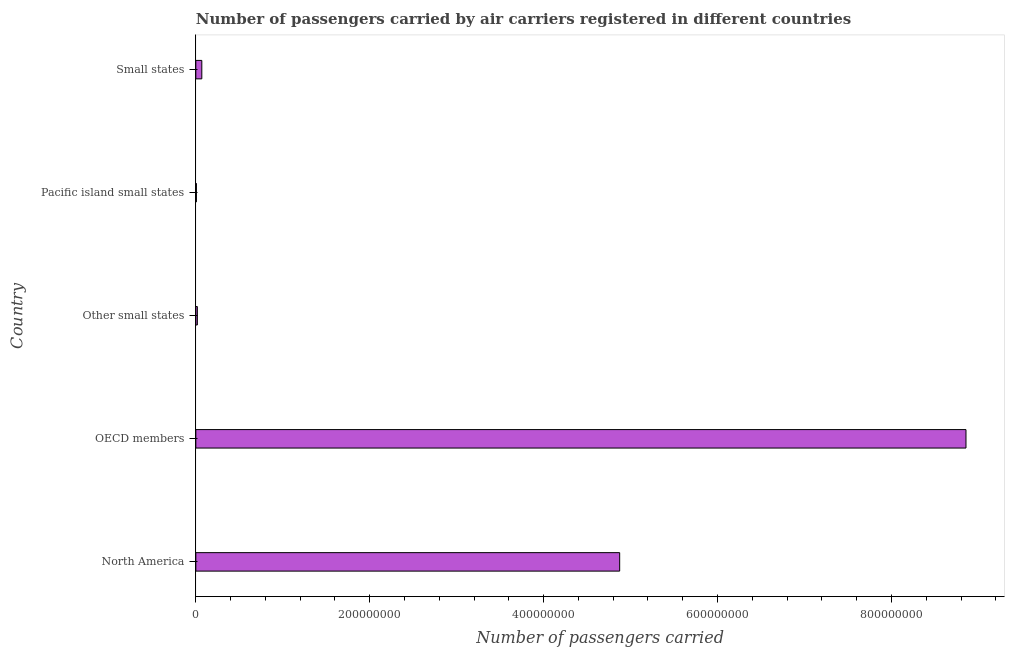Does the graph contain any zero values?
Keep it short and to the point. No. Does the graph contain grids?
Ensure brevity in your answer.  No. What is the title of the graph?
Ensure brevity in your answer.  Number of passengers carried by air carriers registered in different countries. What is the label or title of the X-axis?
Offer a terse response. Number of passengers carried. What is the number of passengers carried in Other small states?
Your answer should be very brief. 1.75e+06. Across all countries, what is the maximum number of passengers carried?
Offer a terse response. 8.86e+08. Across all countries, what is the minimum number of passengers carried?
Keep it short and to the point. 6.70e+05. In which country was the number of passengers carried maximum?
Provide a succinct answer. OECD members. In which country was the number of passengers carried minimum?
Offer a terse response. Pacific island small states. What is the sum of the number of passengers carried?
Your response must be concise. 1.38e+09. What is the difference between the number of passengers carried in OECD members and Other small states?
Give a very brief answer. 8.84e+08. What is the average number of passengers carried per country?
Your answer should be compact. 2.76e+08. What is the median number of passengers carried?
Your answer should be very brief. 6.88e+06. In how many countries, is the number of passengers carried greater than 160000000 ?
Keep it short and to the point. 2. What is the ratio of the number of passengers carried in North America to that in Pacific island small states?
Ensure brevity in your answer.  727.63. Is the number of passengers carried in OECD members less than that in Other small states?
Provide a succinct answer. No. Is the difference between the number of passengers carried in North America and Pacific island small states greater than the difference between any two countries?
Your answer should be compact. No. What is the difference between the highest and the second highest number of passengers carried?
Your response must be concise. 3.98e+08. Is the sum of the number of passengers carried in OECD members and Other small states greater than the maximum number of passengers carried across all countries?
Provide a short and direct response. Yes. What is the difference between the highest and the lowest number of passengers carried?
Provide a succinct answer. 8.85e+08. In how many countries, is the number of passengers carried greater than the average number of passengers carried taken over all countries?
Make the answer very short. 2. How many countries are there in the graph?
Keep it short and to the point. 5. What is the difference between two consecutive major ticks on the X-axis?
Your answer should be compact. 2.00e+08. Are the values on the major ticks of X-axis written in scientific E-notation?
Your response must be concise. No. What is the Number of passengers carried of North America?
Provide a succinct answer. 4.87e+08. What is the Number of passengers carried in OECD members?
Offer a terse response. 8.86e+08. What is the Number of passengers carried in Other small states?
Provide a short and direct response. 1.75e+06. What is the Number of passengers carried in Pacific island small states?
Your answer should be compact. 6.70e+05. What is the Number of passengers carried of Small states?
Give a very brief answer. 6.88e+06. What is the difference between the Number of passengers carried in North America and OECD members?
Give a very brief answer. -3.98e+08. What is the difference between the Number of passengers carried in North America and Other small states?
Provide a short and direct response. 4.86e+08. What is the difference between the Number of passengers carried in North America and Pacific island small states?
Your answer should be compact. 4.87e+08. What is the difference between the Number of passengers carried in North America and Small states?
Your response must be concise. 4.81e+08. What is the difference between the Number of passengers carried in OECD members and Other small states?
Provide a short and direct response. 8.84e+08. What is the difference between the Number of passengers carried in OECD members and Pacific island small states?
Ensure brevity in your answer.  8.85e+08. What is the difference between the Number of passengers carried in OECD members and Small states?
Ensure brevity in your answer.  8.79e+08. What is the difference between the Number of passengers carried in Other small states and Pacific island small states?
Your answer should be very brief. 1.08e+06. What is the difference between the Number of passengers carried in Other small states and Small states?
Give a very brief answer. -5.12e+06. What is the difference between the Number of passengers carried in Pacific island small states and Small states?
Make the answer very short. -6.21e+06. What is the ratio of the Number of passengers carried in North America to that in OECD members?
Your answer should be very brief. 0.55. What is the ratio of the Number of passengers carried in North America to that in Other small states?
Offer a terse response. 277.81. What is the ratio of the Number of passengers carried in North America to that in Pacific island small states?
Make the answer very short. 727.63. What is the ratio of the Number of passengers carried in North America to that in Small states?
Keep it short and to the point. 70.85. What is the ratio of the Number of passengers carried in OECD members to that in Other small states?
Offer a very short reply. 504.81. What is the ratio of the Number of passengers carried in OECD members to that in Pacific island small states?
Provide a short and direct response. 1322.18. What is the ratio of the Number of passengers carried in OECD members to that in Small states?
Offer a very short reply. 128.75. What is the ratio of the Number of passengers carried in Other small states to that in Pacific island small states?
Your answer should be compact. 2.62. What is the ratio of the Number of passengers carried in Other small states to that in Small states?
Offer a terse response. 0.26. What is the ratio of the Number of passengers carried in Pacific island small states to that in Small states?
Your answer should be compact. 0.1. 